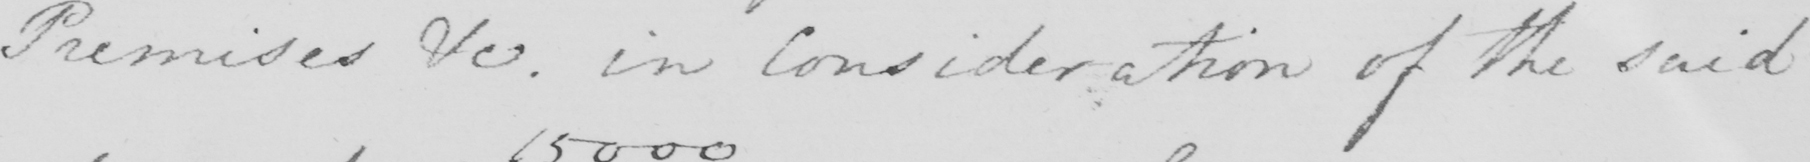What is written in this line of handwriting? Premises &c . in Consideration of the said 